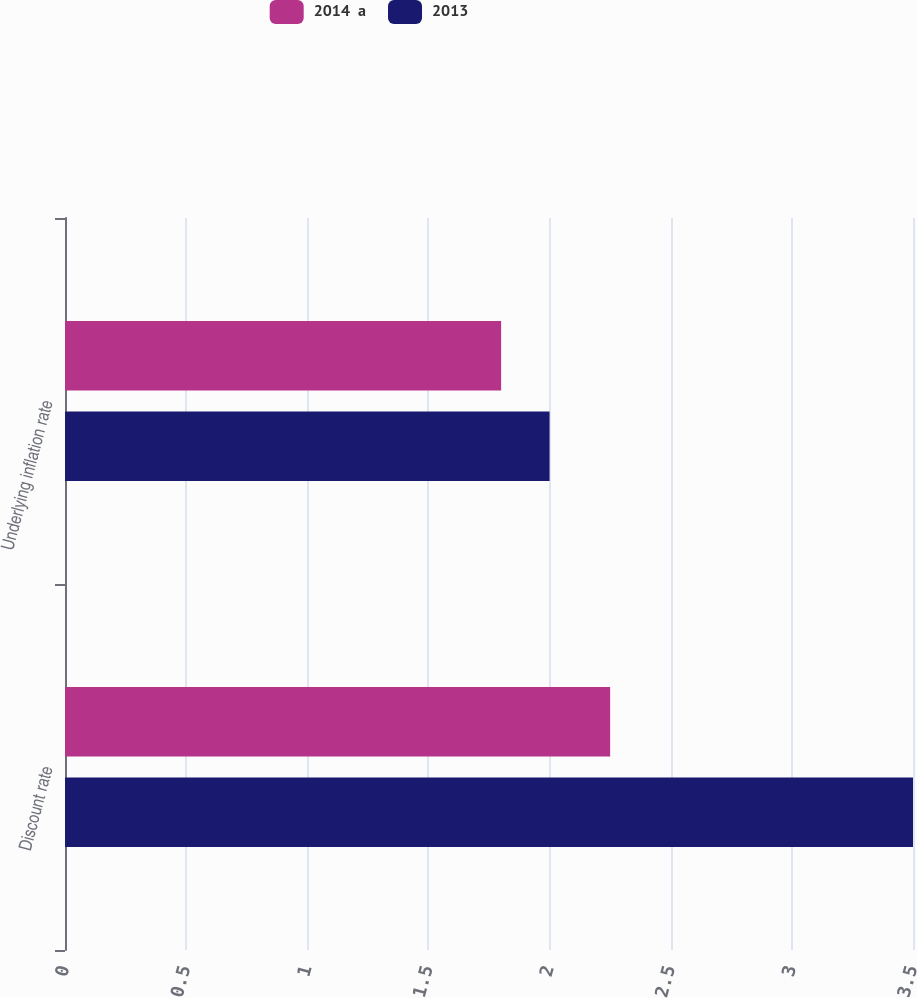Convert chart to OTSL. <chart><loc_0><loc_0><loc_500><loc_500><stacked_bar_chart><ecel><fcel>Discount rate<fcel>Underlying inflation rate<nl><fcel>2014  a<fcel>2.25<fcel>1.8<nl><fcel>2013<fcel>3.5<fcel>2<nl></chart> 